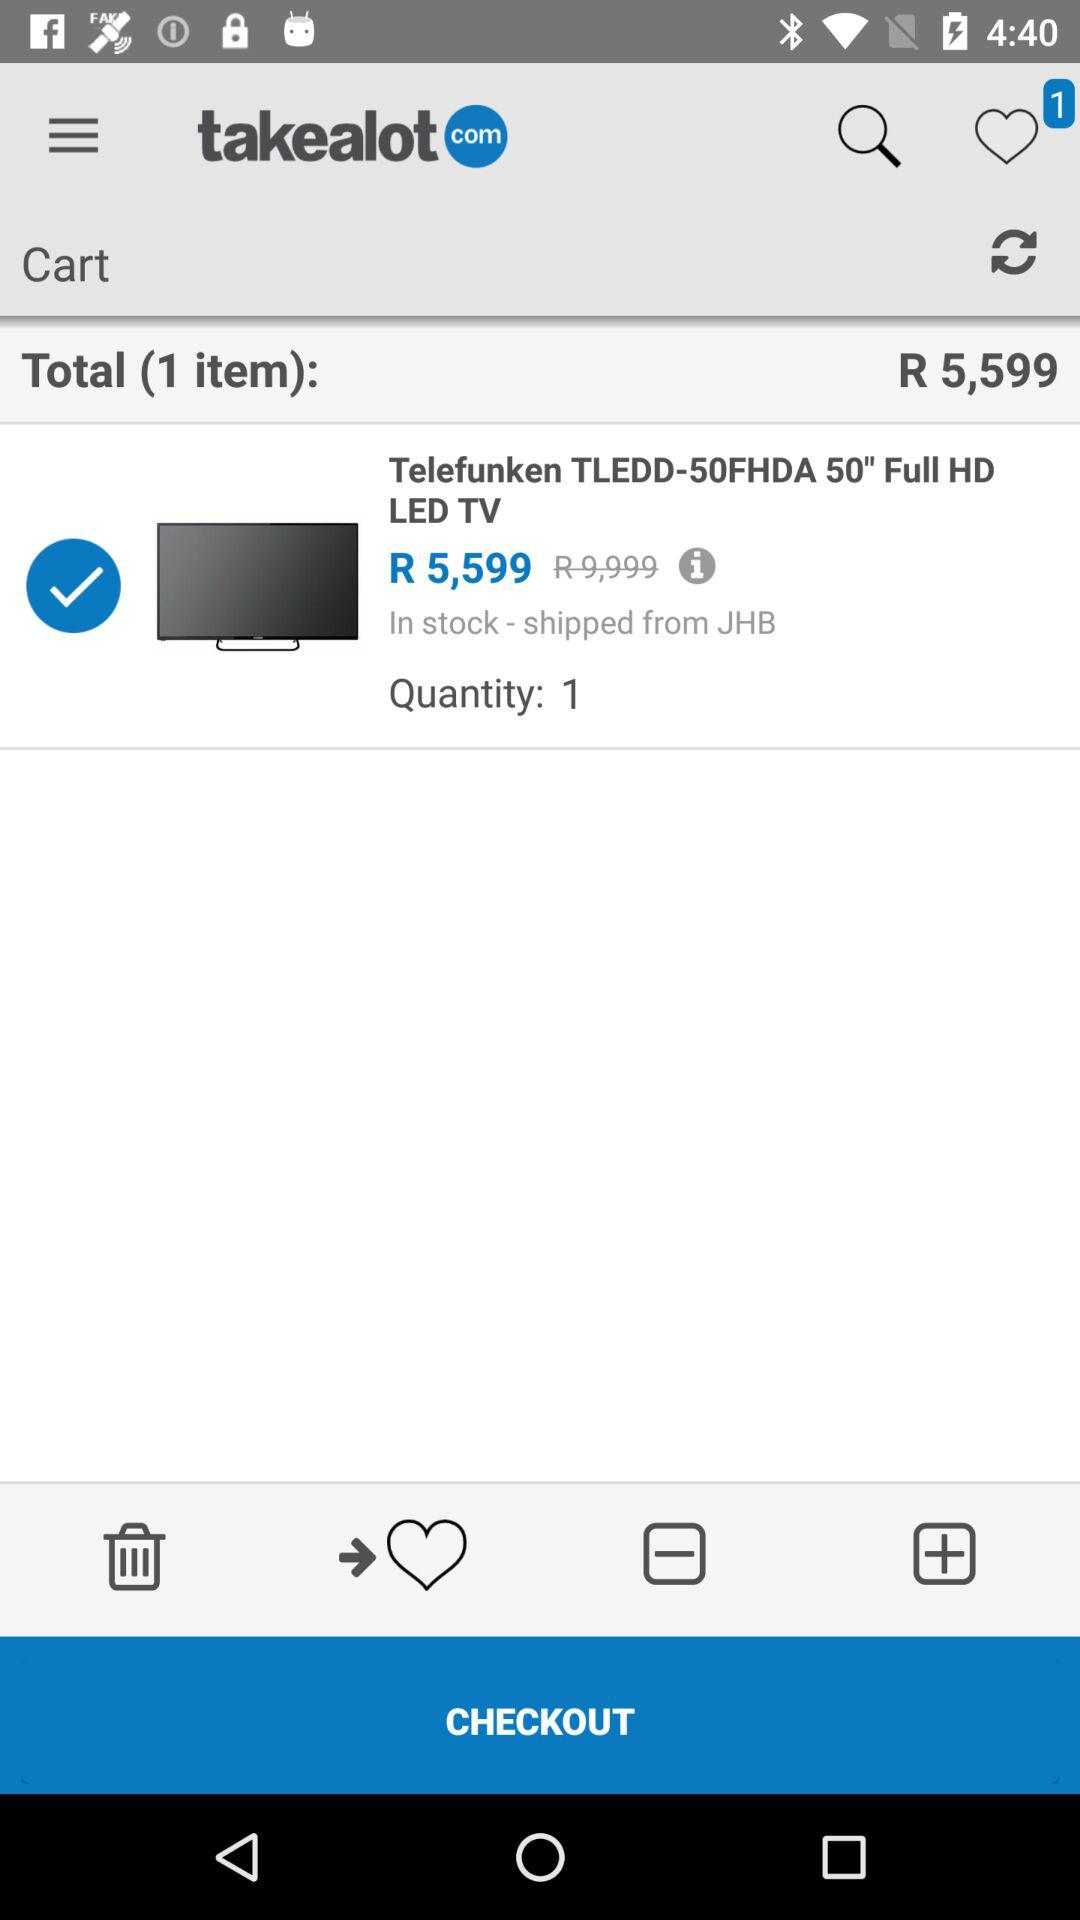What is the cost of the item? The cost of the item is R 5,599. 